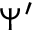<formula> <loc_0><loc_0><loc_500><loc_500>\Psi ^ { \prime }</formula> 